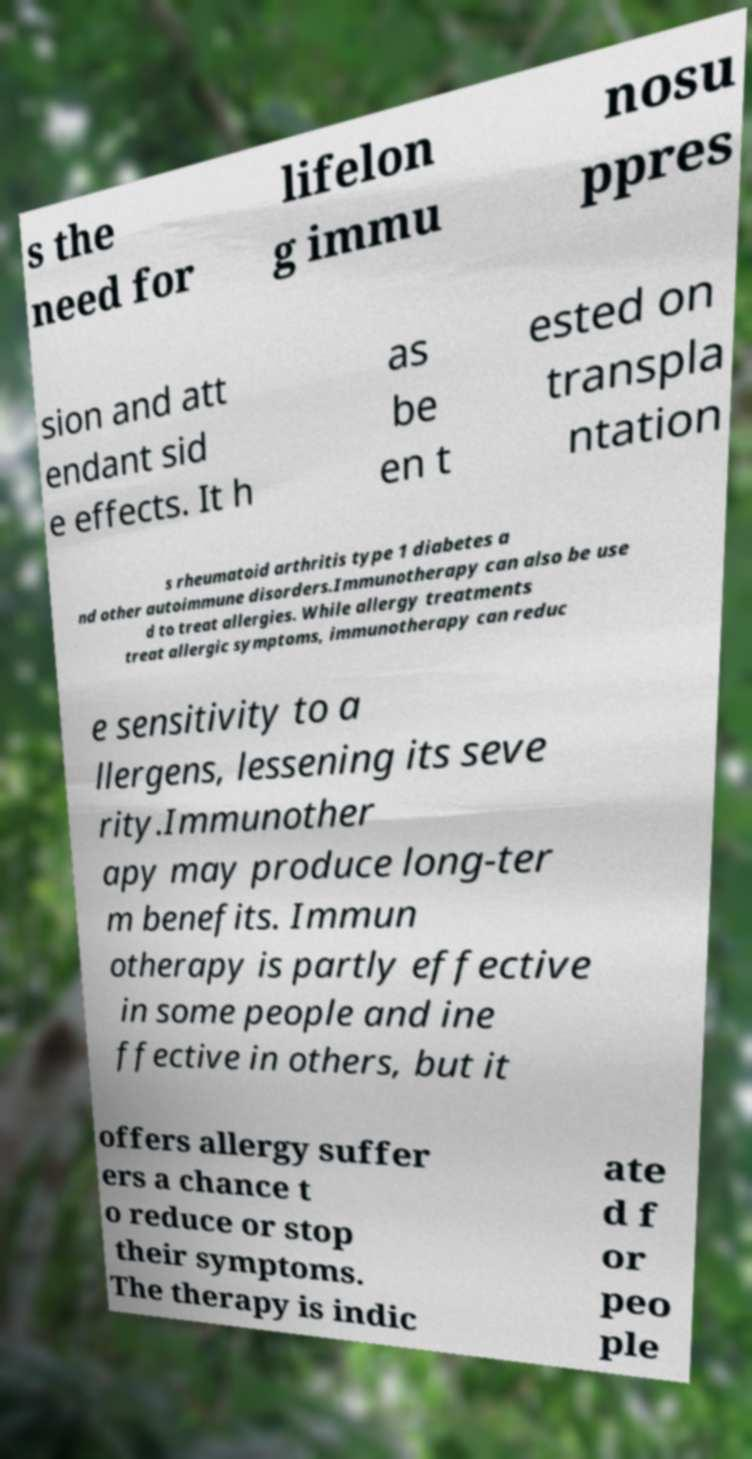Could you extract and type out the text from this image? s the need for lifelon g immu nosu ppres sion and att endant sid e effects. It h as be en t ested on transpla ntation s rheumatoid arthritis type 1 diabetes a nd other autoimmune disorders.Immunotherapy can also be use d to treat allergies. While allergy treatments treat allergic symptoms, immunotherapy can reduc e sensitivity to a llergens, lessening its seve rity.Immunother apy may produce long-ter m benefits. Immun otherapy is partly effective in some people and ine ffective in others, but it offers allergy suffer ers a chance t o reduce or stop their symptoms. The therapy is indic ate d f or peo ple 